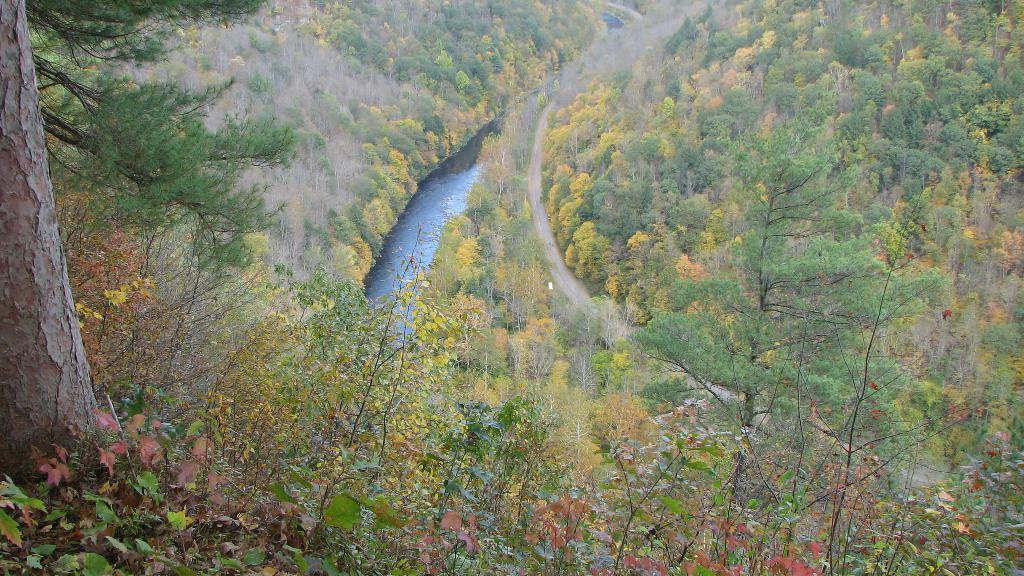What type of vegetation can be seen in the image? There are plants and trees visible in the image. What natural element is present in the image? There is water visible in the image. What surface can be seen in the image? The ground is visible in the image. What type of cork can be seen floating in the water in the image? There is no cork present in the image; only plants, trees, water, and the ground are visible. 